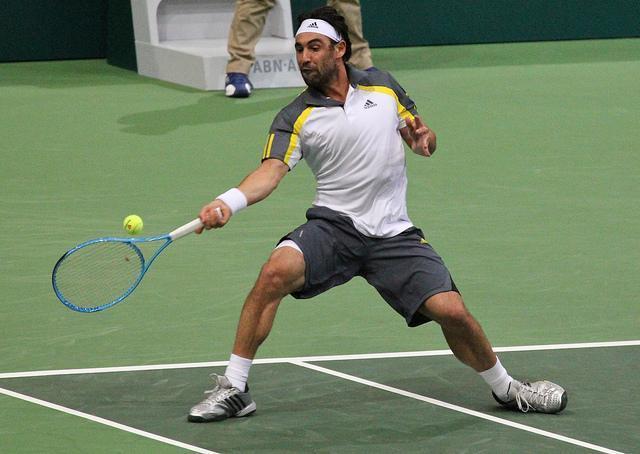How many people are there?
Give a very brief answer. 2. 